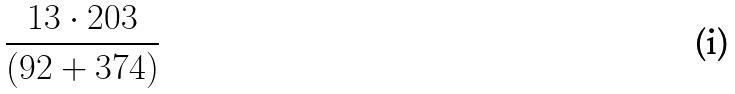Convert formula to latex. <formula><loc_0><loc_0><loc_500><loc_500>\frac { 1 3 \cdot 2 0 3 } { ( 9 2 + 3 7 4 ) }</formula> 